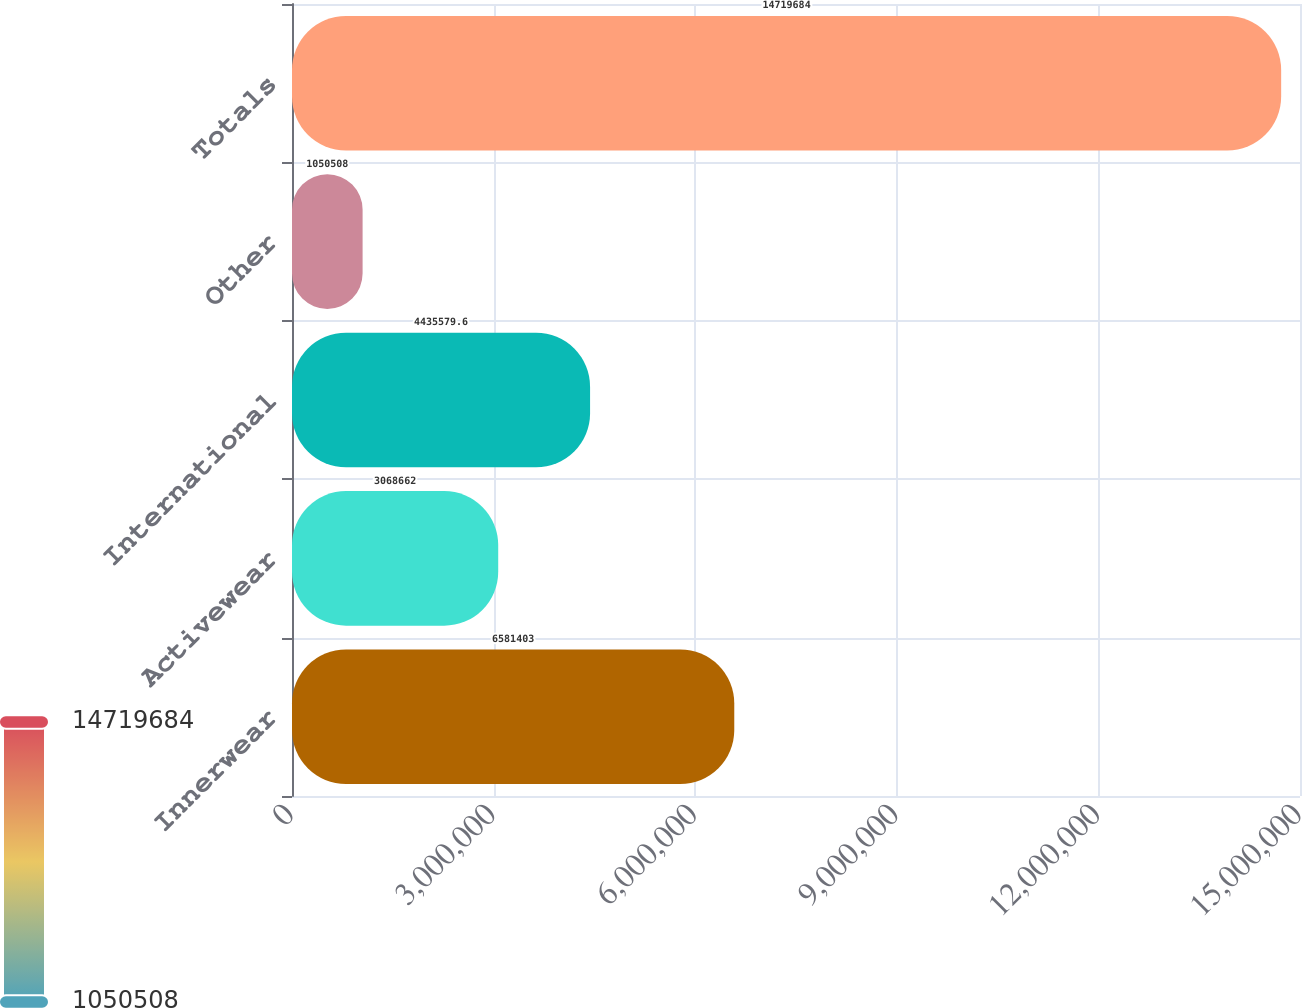Convert chart. <chart><loc_0><loc_0><loc_500><loc_500><bar_chart><fcel>Innerwear<fcel>Activewear<fcel>International<fcel>Other<fcel>Totals<nl><fcel>6.5814e+06<fcel>3.06866e+06<fcel>4.43558e+06<fcel>1.05051e+06<fcel>1.47197e+07<nl></chart> 